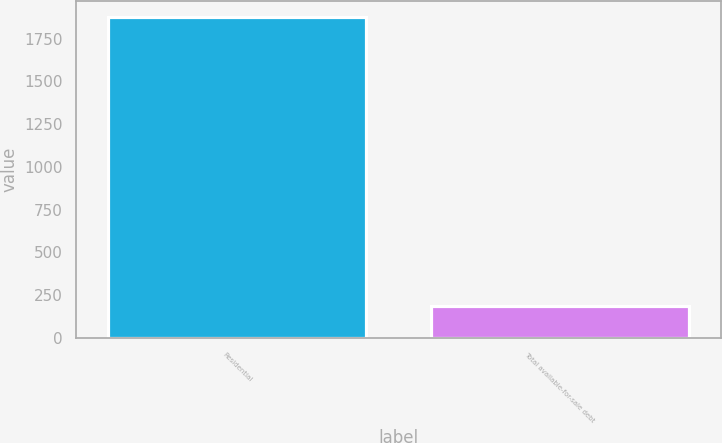Convert chart to OTSL. <chart><loc_0><loc_0><loc_500><loc_500><bar_chart><fcel>Residential<fcel>Total available-for-sale debt<nl><fcel>1876<fcel>186<nl></chart> 